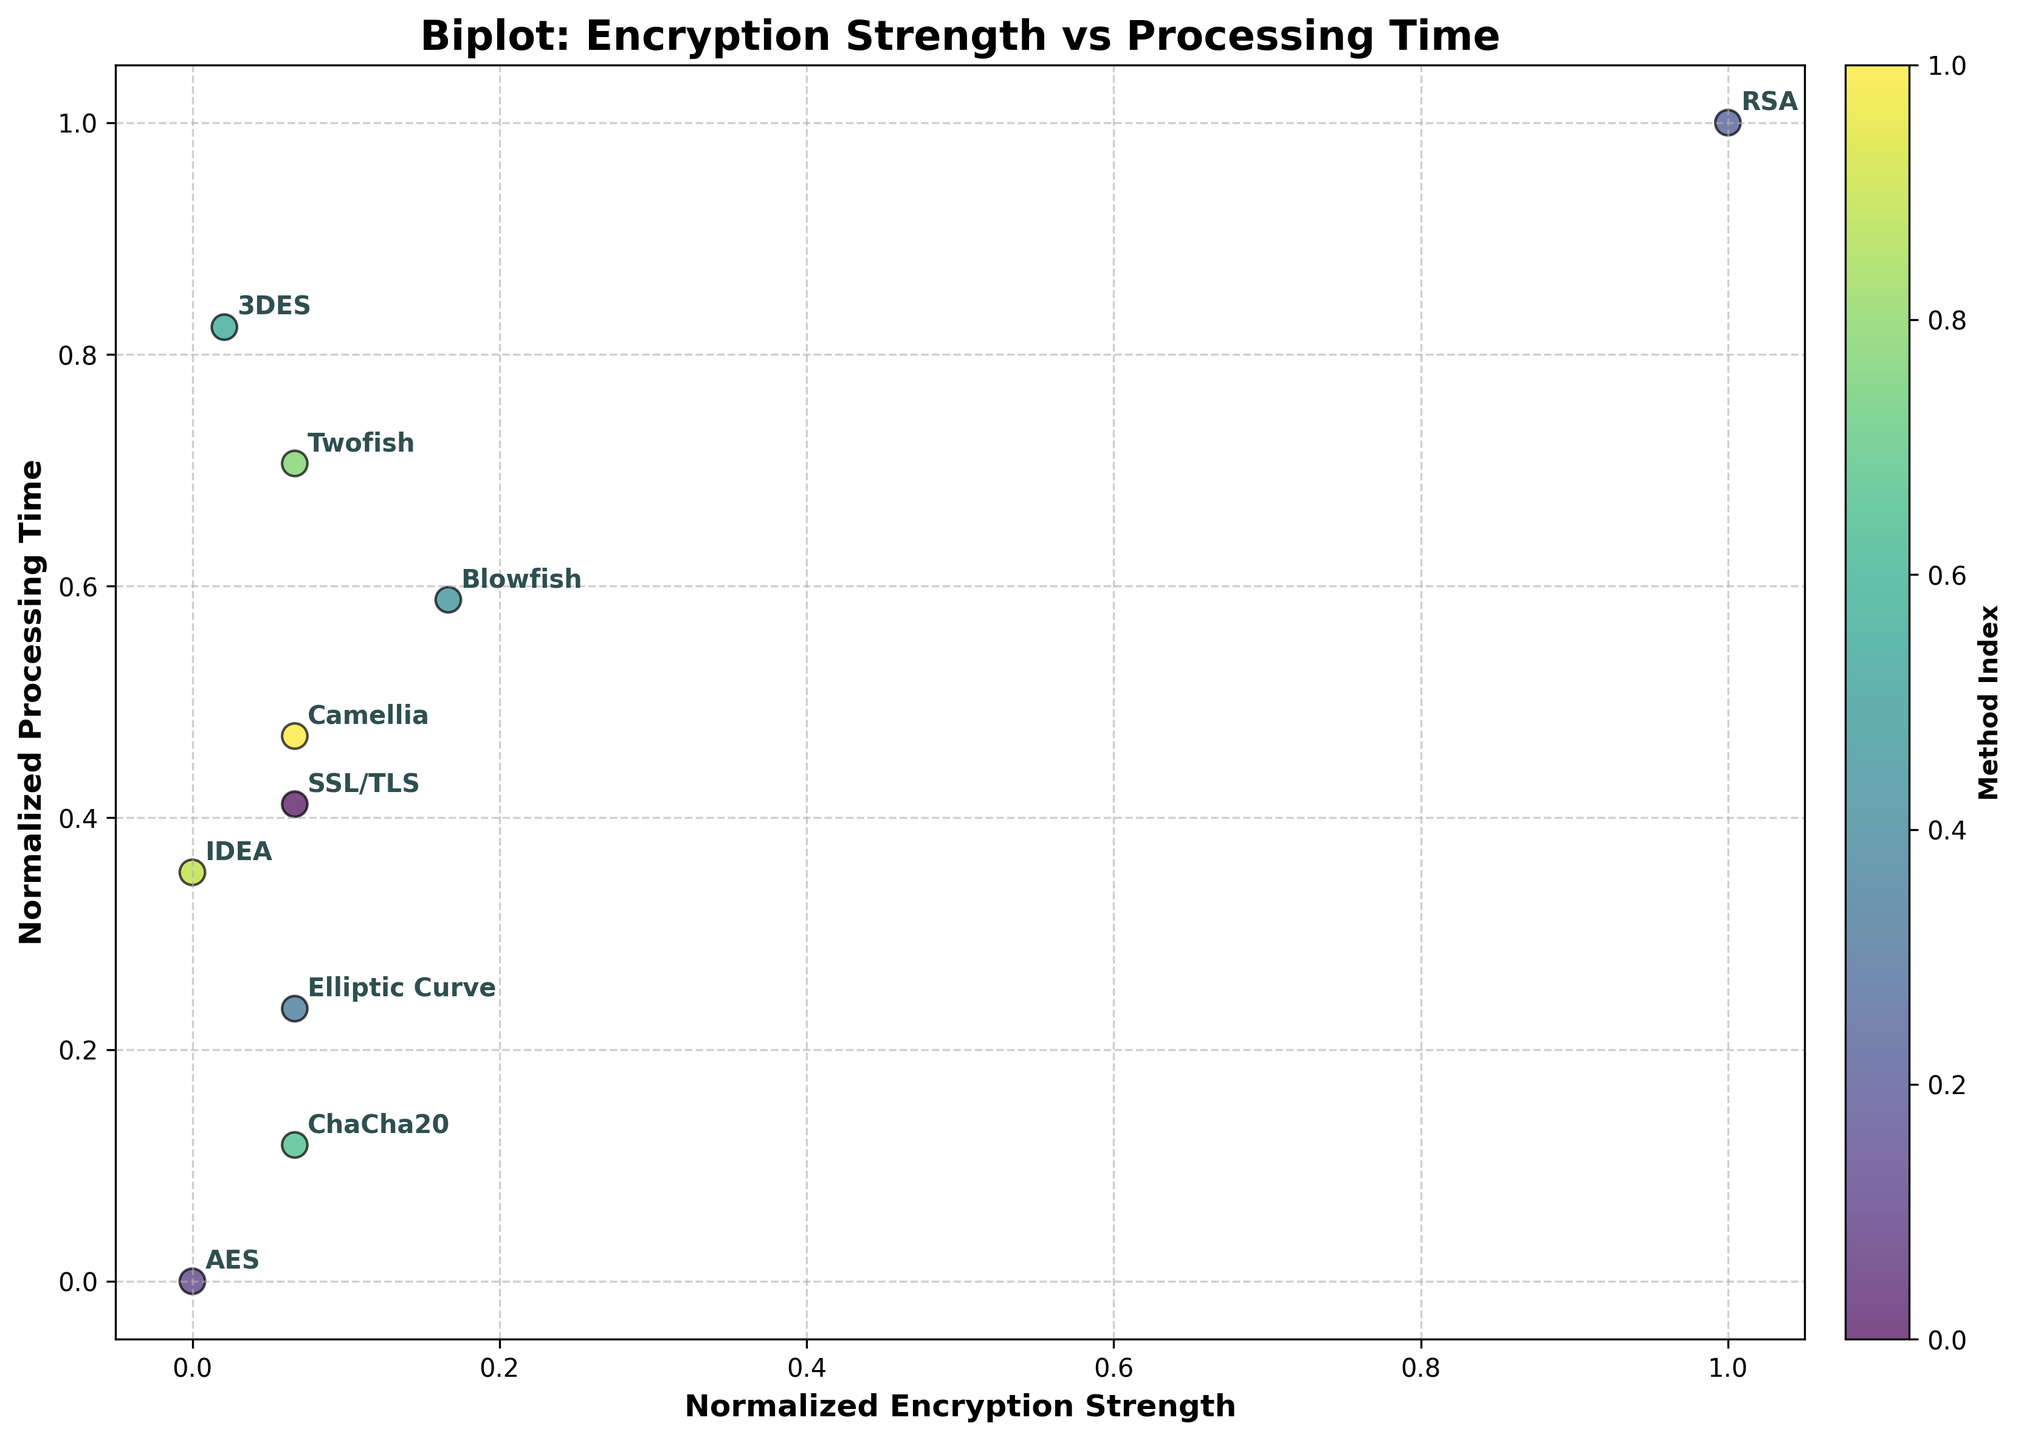What is the title of the plot? The title of the plot is displayed at the top and summarizes what the plot depicts.
Answer: Biplot: Encryption Strength vs Processing Time How many methods of online transaction encryption are compared in the plot? Count the number of unique method labels annotated in the plot.
Answer: 10 Which method has the highest encryption strength? Look for the method positioned furthest to the right along the normalized encryption strength axis.
Answer: Blowfish Which method has the lowest processing time? Identify the method positioned lowest on the normalized processing time axis.
Answer: AES Which encryption method offers a balance between high encryption strength and low processing time? Look for a method that is relatively high on the encryption strength axis but also low on the processing time axis.
Answer: ChaCha20 What's the difference in normalized encryption strength between 3DES and RSA? Find the normalized encryption strength for both 3DES and RSA and subtract the smaller value from the larger value. Based on the normalized scale, note their respective positions.
Answer: 3DES: 0.28 (approx.), RSA: 0.818 (approx.), Difference: 0.538 (approx.) Which method falls closest to the average on both normalized encryption strength and processing time axes? Calculate the average point for both axes (0.5 for a normalized scale) and see which method is closest to this central point.
Answer: SSL/TLS How does the processing time of Elliptic Curve compare to that of Twofish? Compare the normalized heights (y-axis position) of Elliptic Curve and Twofish and identify which is higher or lower.
Answer: Elliptic Curve is lower If prioritizing encryption strength over processing time, which two methods would you consider? Identify the two methods with the highest positions on the normalized encryption strength axis.
Answer: Blowfish and RSA Which methods have an encryption strength of 256? Identify all methods whose annotations align horizontally with the specific value on the normalized encryption strength axis.
Answer: SSL/TLS, Elliptic Curve, ChaCha20, Twofish, Camellia 